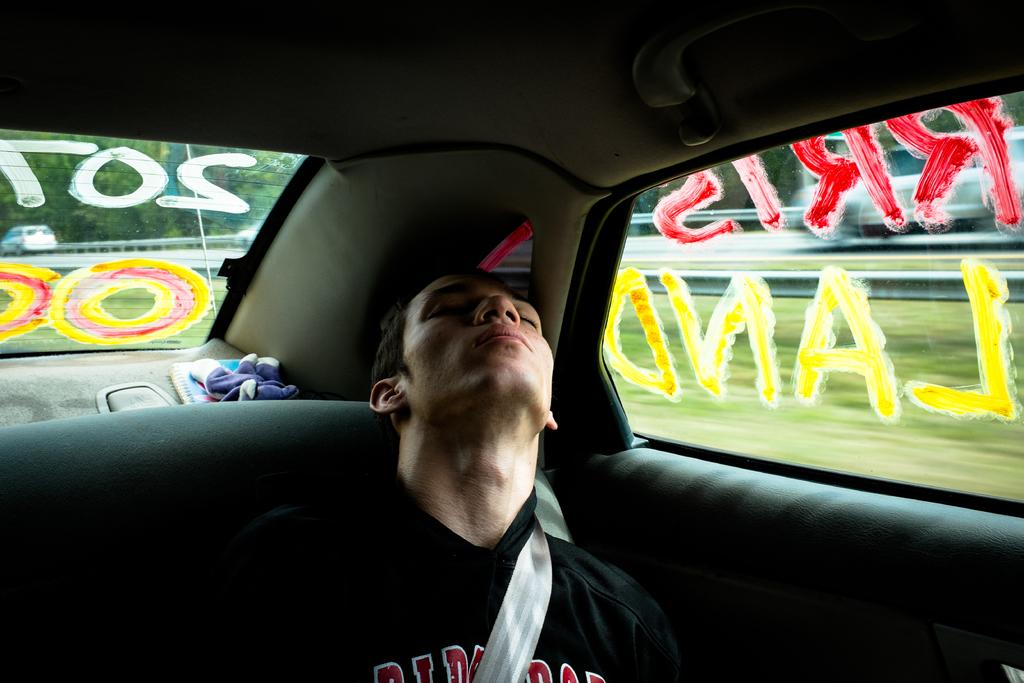What is the main subject of the image? The main subject of the image is a man. What is the man doing in the image? The man is sleeping in the image. Where is the man located in the image? The man is inside a car in the image. What number is associated with the scene in the image? There is no specific number associated with the scene in the image. What type of low-quality material is present in the image? There is no low-quality material present in the image. 